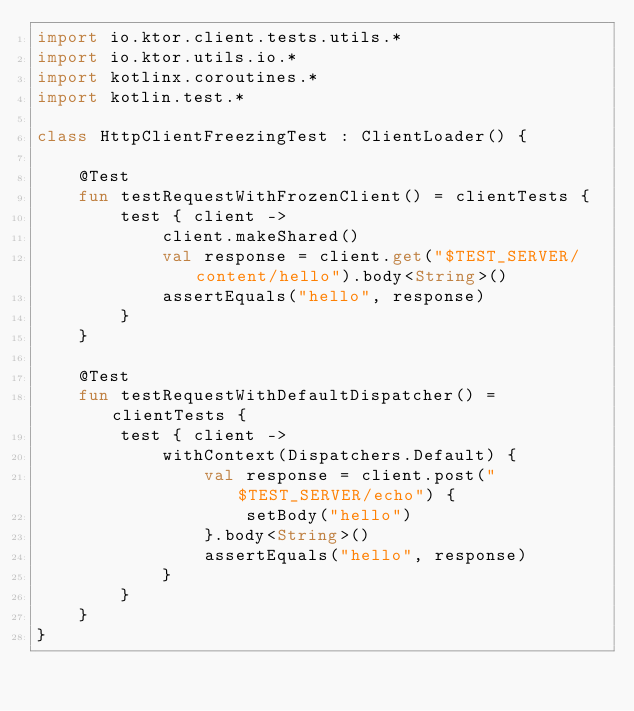<code> <loc_0><loc_0><loc_500><loc_500><_Kotlin_>import io.ktor.client.tests.utils.*
import io.ktor.utils.io.*
import kotlinx.coroutines.*
import kotlin.test.*

class HttpClientFreezingTest : ClientLoader() {

    @Test
    fun testRequestWithFrozenClient() = clientTests {
        test { client ->
            client.makeShared()
            val response = client.get("$TEST_SERVER/content/hello").body<String>()
            assertEquals("hello", response)
        }
    }

    @Test
    fun testRequestWithDefaultDispatcher() = clientTests {
        test { client ->
            withContext(Dispatchers.Default) {
                val response = client.post("$TEST_SERVER/echo") {
                    setBody("hello")
                }.body<String>()
                assertEquals("hello", response)
            }
        }
    }
}
</code> 